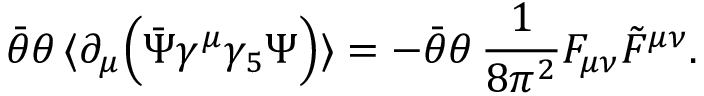<formula> <loc_0><loc_0><loc_500><loc_500>\bar { \theta } \theta \, \langle \partial _ { \mu } \left ( \bar { \Psi } \gamma ^ { \mu } \gamma _ { 5 } \Psi \right ) \rangle = - \bar { \theta } \theta \, \frac { 1 } { 8 \pi ^ { 2 } } F _ { \mu \nu } \tilde { F } ^ { \mu \nu } .</formula> 